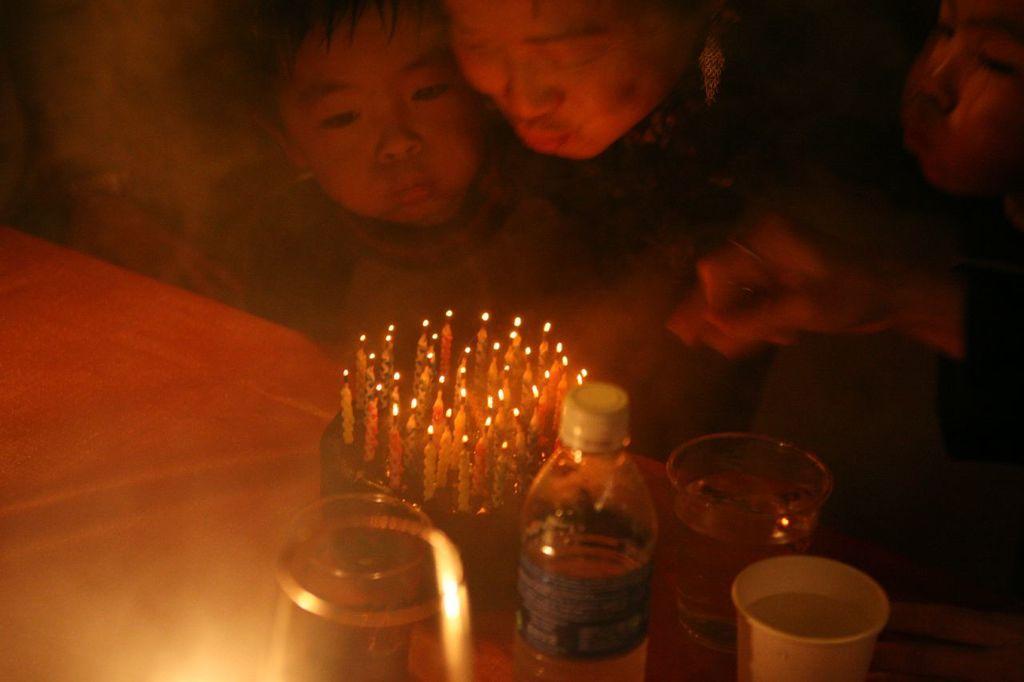In one or two sentences, can you explain what this image depicts? In this image I can see a table. On that there is a coke, bottle and glasses. It seems like a baby celebrating the birthday. In the background I can see few people are standing in front of the table. 